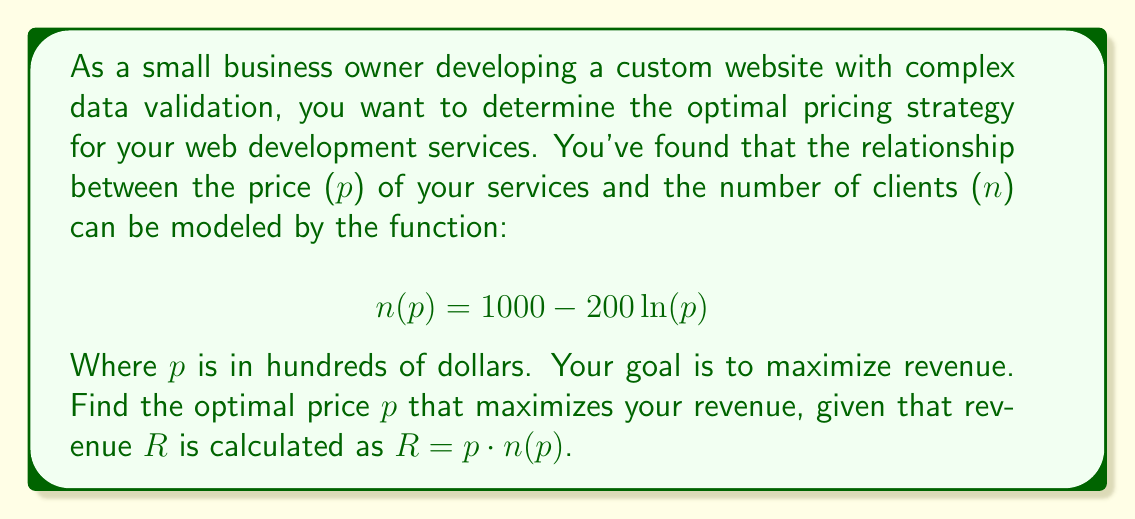Provide a solution to this math problem. To solve this problem, we'll follow these steps:

1) First, let's express the revenue function $R(p)$ in terms of $p$:
   $$R(p) = p \cdot n(p) = p(1000 - 200\ln(p)) = 1000p - 200p\ln(p)$$

2) To find the maximum revenue, we need to find where the derivative of $R(p)$ equals zero:
   $$\frac{dR}{dp} = 1000 - 200\ln(p) - 200 = 800 - 200\ln(p)$$

3) Set this equal to zero:
   $$800 - 200\ln(p) = 0$$

4) Solve for $p$:
   $$200\ln(p) = 800$$
   $$\ln(p) = 4$$
   $$p = e^4 \approx 54.60$$

5) To confirm this is a maximum, we can check the second derivative:
   $$\frac{d^2R}{dp^2} = -\frac{200}{p}$$
   
   This is negative for all positive $p$, confirming we've found a maximum.

6) Remember that $p$ is in hundreds of dollars, so we need to multiply by 100 to get the actual price in dollars.
Answer: The optimal price that maximizes revenue is $p = e^4 \cdot 100 \approx \$5,459.82$. 